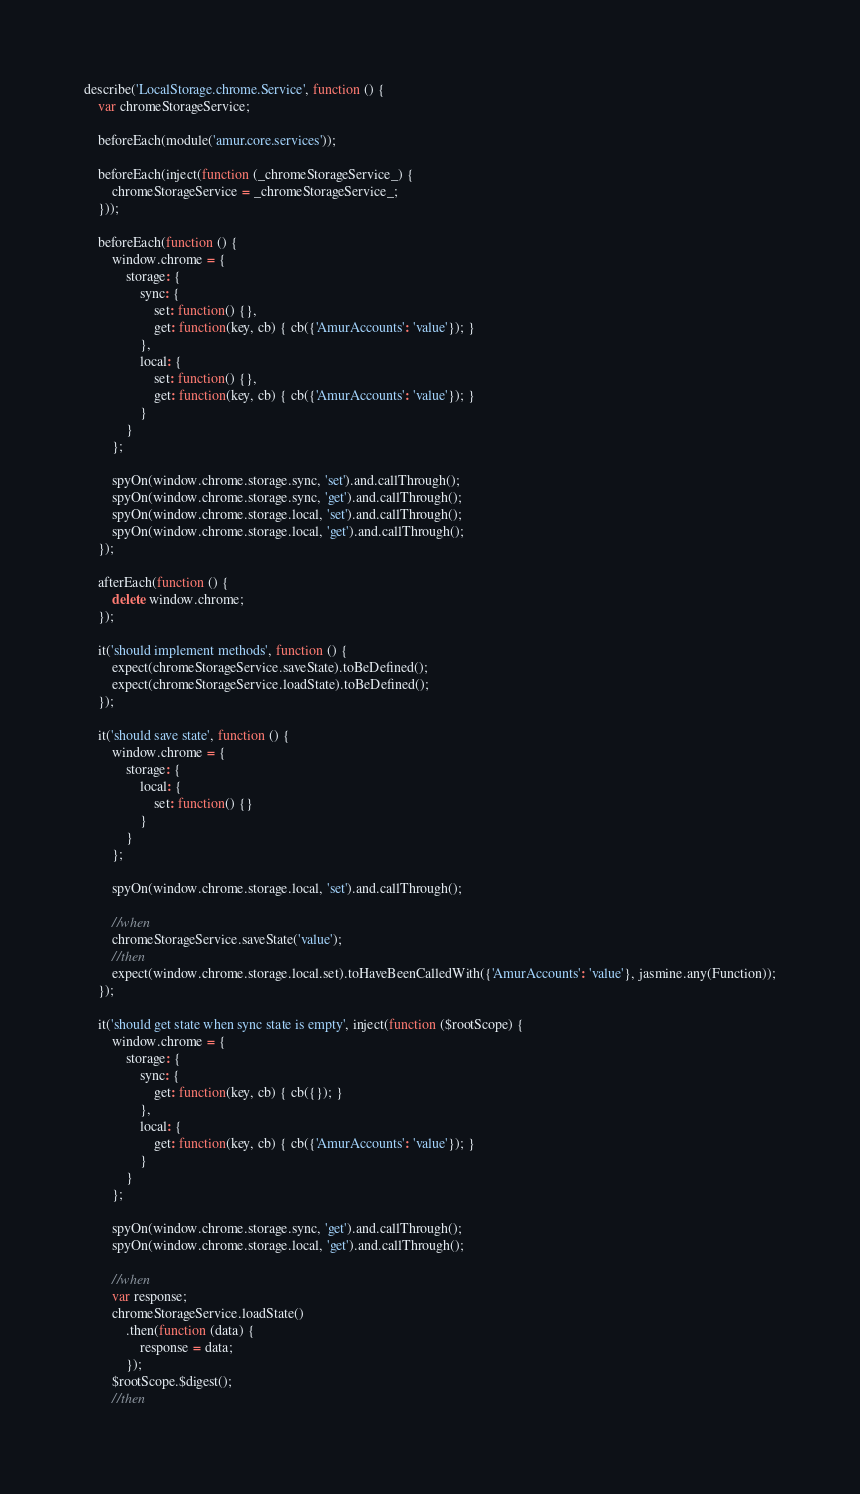Convert code to text. <code><loc_0><loc_0><loc_500><loc_500><_JavaScript_>describe('LocalStorage.chrome.Service', function () {
    var chromeStorageService;

    beforeEach(module('amur.core.services'));

    beforeEach(inject(function (_chromeStorageService_) {
        chromeStorageService = _chromeStorageService_;
    }));

    beforeEach(function () {
        window.chrome = {
            storage: {
                sync: {
                    set: function() {},
                    get: function(key, cb) { cb({'AmurAccounts': 'value'}); }
                },
                local: {
                    set: function() {},
                    get: function(key, cb) { cb({'AmurAccounts': 'value'}); }
                }
            }
        };

        spyOn(window.chrome.storage.sync, 'set').and.callThrough();
        spyOn(window.chrome.storage.sync, 'get').and.callThrough();
        spyOn(window.chrome.storage.local, 'set').and.callThrough();
        spyOn(window.chrome.storage.local, 'get').and.callThrough();
    });

    afterEach(function () {
        delete window.chrome;
    });

    it('should implement methods', function () {
        expect(chromeStorageService.saveState).toBeDefined();
        expect(chromeStorageService.loadState).toBeDefined();
    });

    it('should save state', function () {
        window.chrome = {
            storage: {
                local: {
                    set: function() {}
                }
            }
        };

        spyOn(window.chrome.storage.local, 'set').and.callThrough();

        //when
        chromeStorageService.saveState('value');
        //then
        expect(window.chrome.storage.local.set).toHaveBeenCalledWith({'AmurAccounts': 'value'}, jasmine.any(Function));
    });

    it('should get state when sync state is empty', inject(function ($rootScope) {
        window.chrome = {
            storage: {
                sync: {
                    get: function(key, cb) { cb({}); }
                },
                local: {
                    get: function(key, cb) { cb({'AmurAccounts': 'value'}); }
                }
            }
        };

        spyOn(window.chrome.storage.sync, 'get').and.callThrough();
        spyOn(window.chrome.storage.local, 'get').and.callThrough();

        //when
        var response;
        chromeStorageService.loadState()
            .then(function (data) {
                response = data;
            });
        $rootScope.$digest();
        //then</code> 